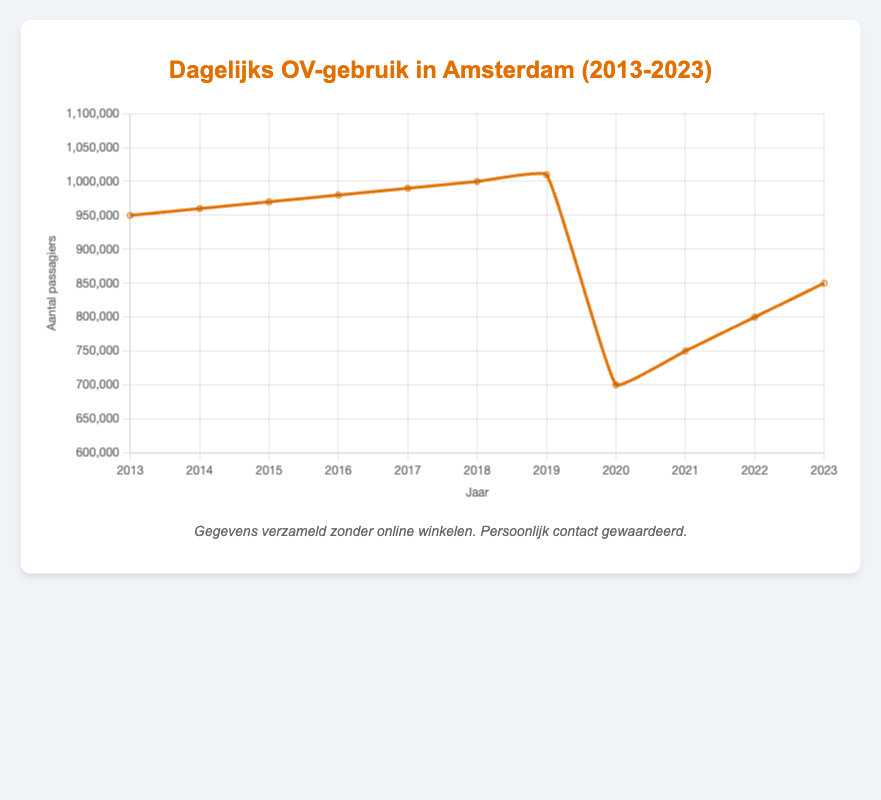What was the average daily number of passengers in 2014? The figure shows that the average daily number of passengers in Amsterdam for the year 2014 is marked directly on the curve.
Answer: 960,000 In which year did the average daily passengers reach 1,000,000? By inspecting the curve, the data point indicating when the average daily passengers reached 1,000,000 is labeled at the year 2018.
Answer: 2018 How did the number of daily passengers change from 2019 to 2020? By comparing the data points for 2019 and 2020, the average daily passengers dropped from 1,010,000 in 2019 to 700,000 in 2020. This indicates a decrease.
Answer: Decrease by 310,000 Which year had the lowest average daily number of passengers, and what was the value? The lowest data point on the curve can be seen at 2020, and the value marked is 700,000.
Answer: 2020, 700,000 What is the overall trend in average daily passengers between 2013 and 2023? Observing the curve, there is a general upward trend from 2013 to 2019, followed by a significant drop in 2020, with a partial recovery from 2021 to 2023.
Answer: Upward trend with a drop in 2020 Calculate the average daily number of passengers over the decade from 2013 to 2023. Sum the average daily passengers for each year and divide by the number of years: (950,000 + 960,000 + 970,000 + 980,000 + 990,000 + 1,000,000 + 1,010,000 + 700,000 + 750,000 + 800,000 + 850,000) / 11 = 870,000.
Answer: 870,000 Compare the average daily passengers between 2016 and 2022. Which year had more passengers? Inspect the data points for 2016 and 2022; 2016 had 980,000 passengers while 2022 had 800,000. Thus 2016 had more passengers.
Answer: 2016 From 2020 to 2023, how has the number of daily passengers changed each year? By looking at the figures, from 2020 (700,000) to 2021 (750,000), there is an increase of 50,000. From 2021 to 2022 (800,000), an increase of 50,000 again. From 2022 to 2023 (850,000), there is also an increase of 50,000. This shows a consistent annual increase of 50,000 passengers each year from 2020 to 2023.
Answer: Increase by 50,000 each year Which has the higher average number of daily passengers: the period from 2013-2018 or the period from 2019-2023? Calculate the average for each period. First period: (950,000 + 960,000 + 970,000 + 980,000 + 990,000 + 1,000,000) / 6 = 975,000. Second period: (1,010,000 + 700,000 + 750,000 + 800,000 + 850,000) / 5 = 822,000. The period 2013-2018 has a higher average.
Answer: 2013-2018 